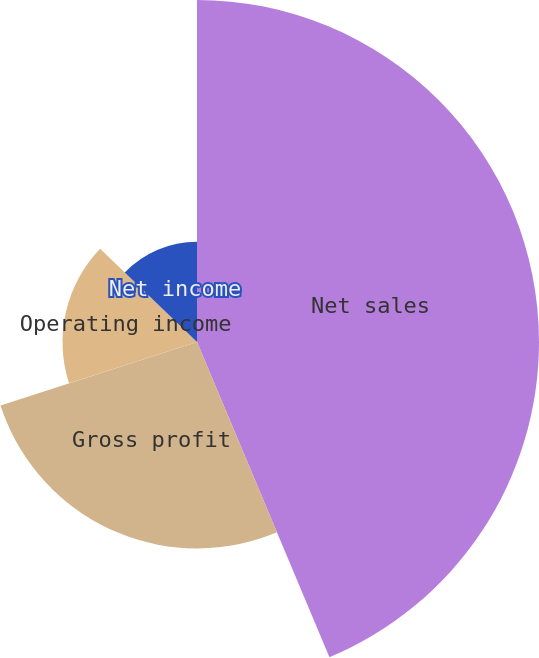<chart> <loc_0><loc_0><loc_500><loc_500><pie_chart><fcel>Net sales<fcel>Gross profit<fcel>Operating income<fcel>Net income<fcel>Diluted net income per common<nl><fcel>43.67%<fcel>26.36%<fcel>17.17%<fcel>12.8%<fcel>0.0%<nl></chart> 